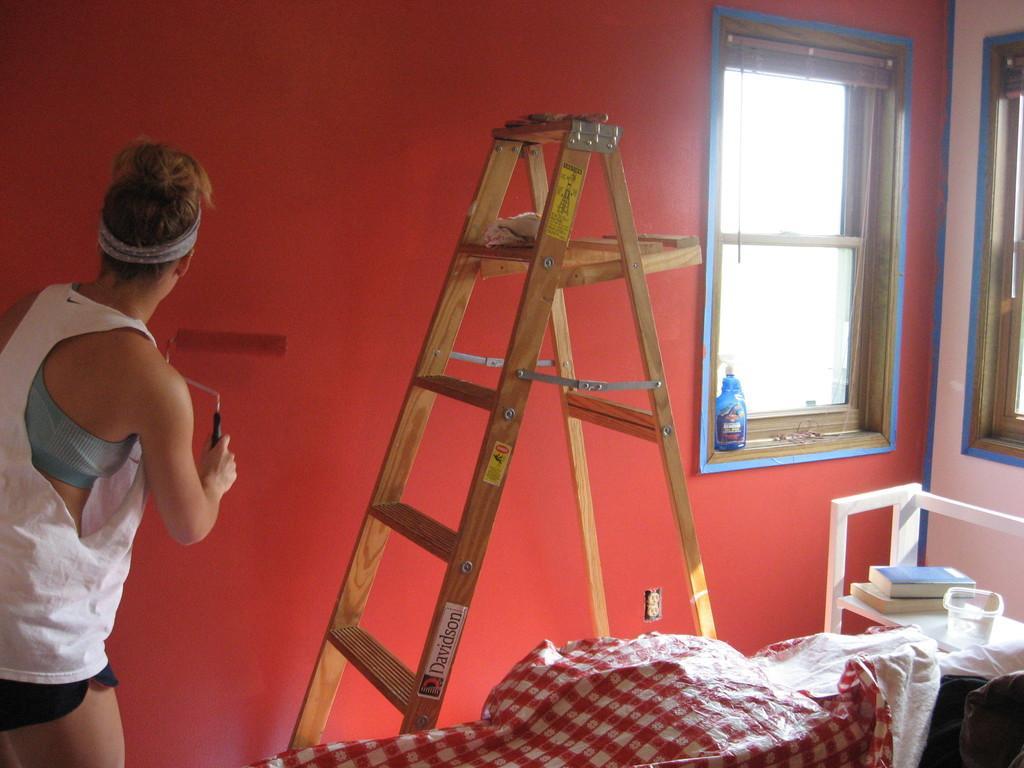Please provide a concise description of this image. In the picture we can see the interior of the house with a red color wall and a window to it and near it, we can see some rack to the floor and some books on it and beside it, we can see a cloth and a wooden ladder and a person standing near it and doing some repair to the wall. 